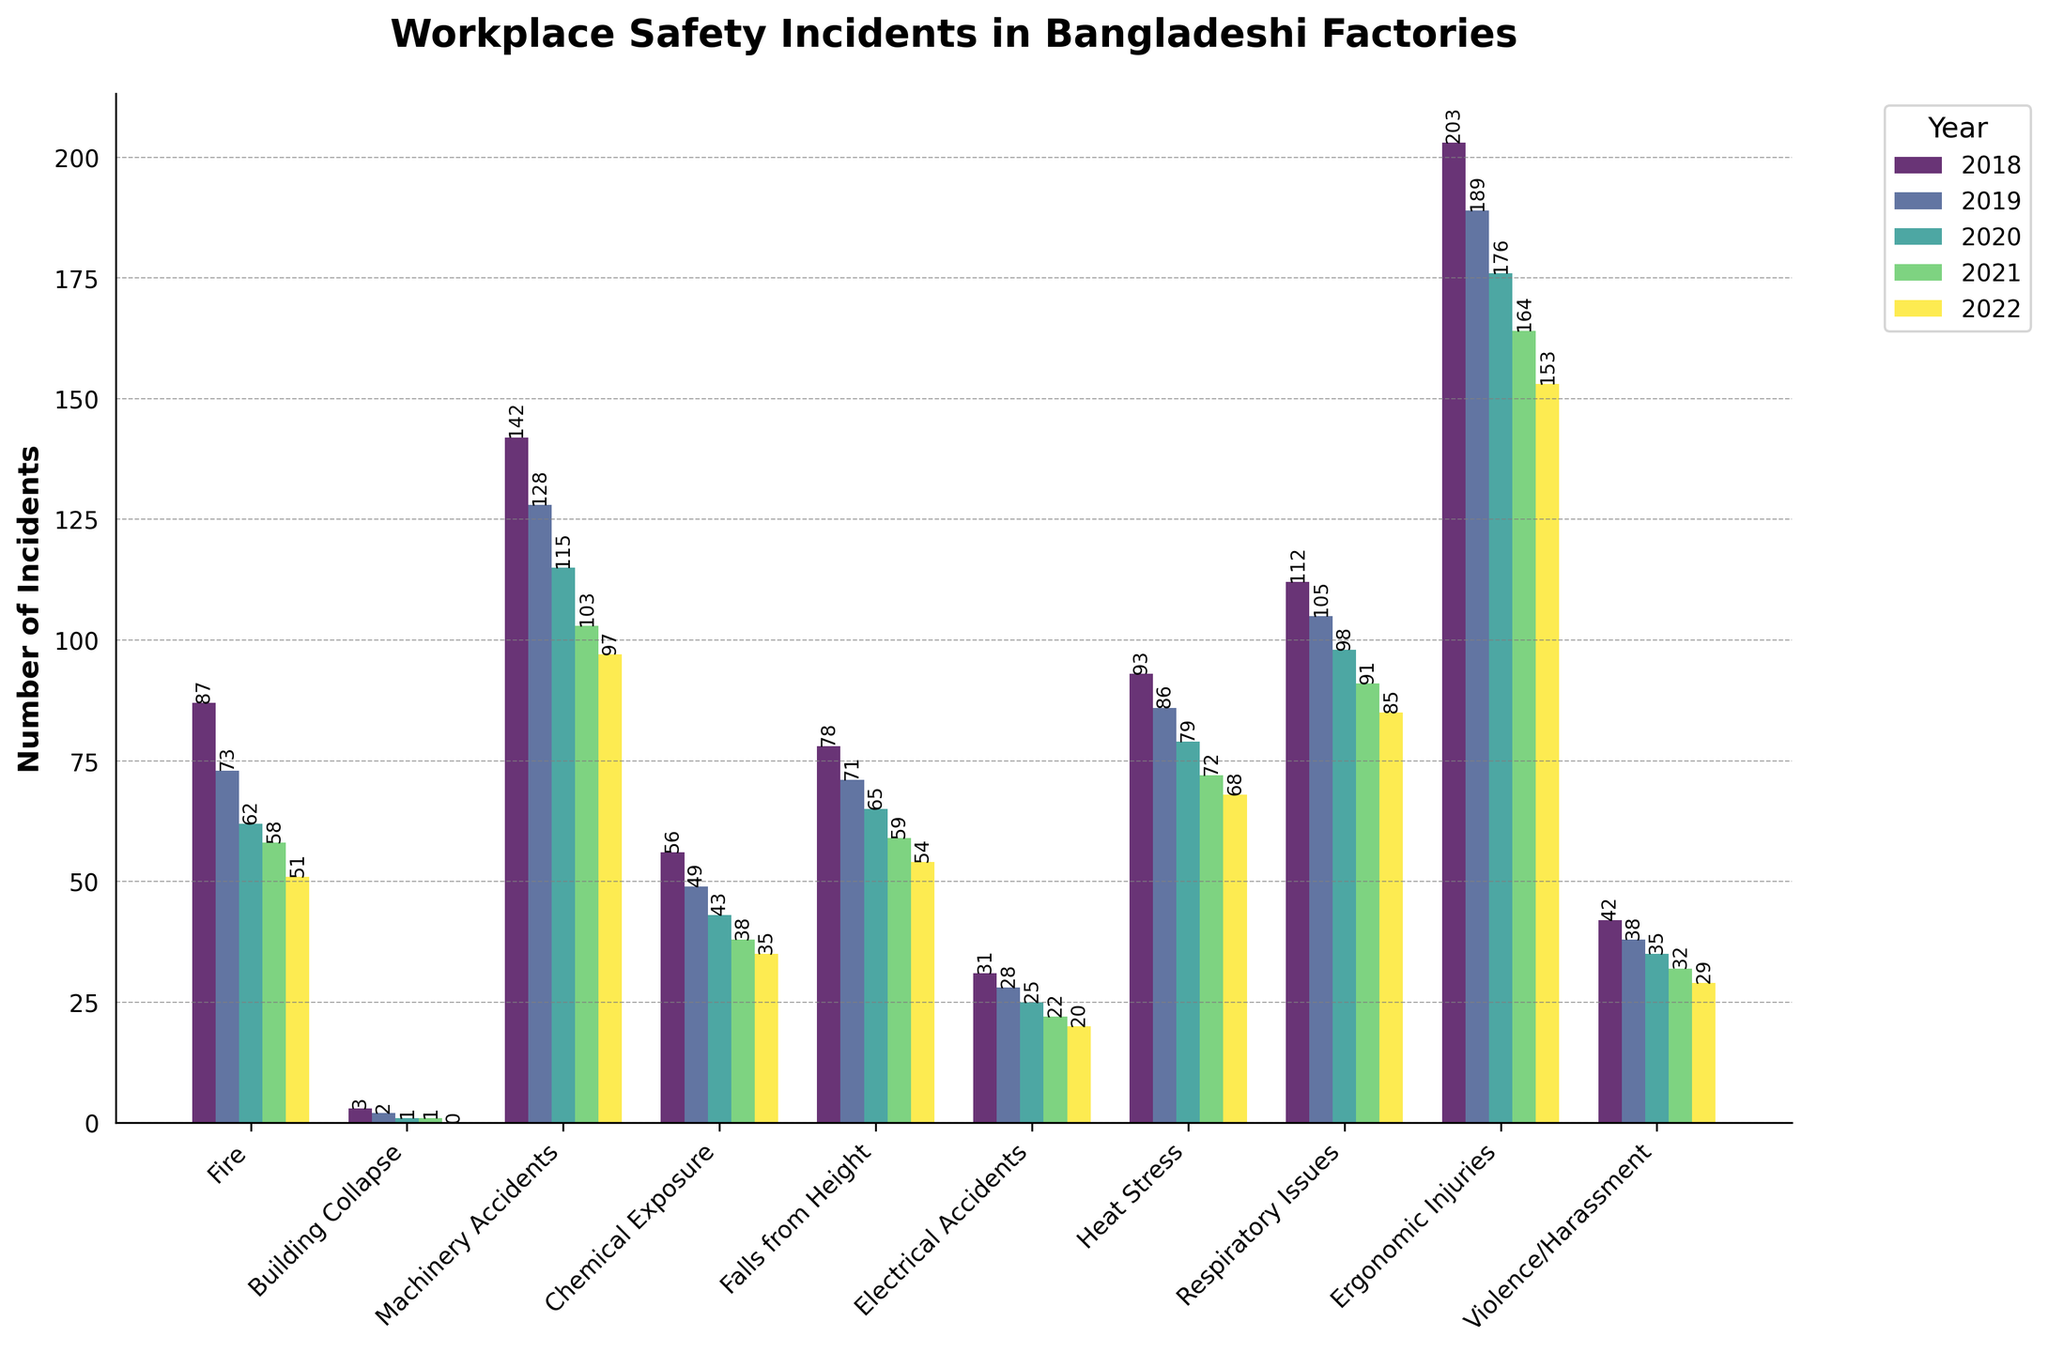What's the most common type of incident in 2022? From the bar chart, find the tallest bar for the year 2022. The tallest bar corresponds to "Ergonomic Injuries"
Answer: Ergonomic Injuries Compare the number of Fire incidents between 2018 and 2022. Which year had more incidents? Locate the bars corresponding to Fire incidents for 2018 and 2022, then compare their heights. 2018 has a taller bar
Answer: 2018 What is the total number of Machinery Accidents over the 5 years? Sum the values of Machinery Accidents for each year: 142 (2018) + 128 (2019) + 115 (2020) + 103 (2021) + 97 (2022) = 585
Answer: 585 Which type of incident decreased the most from 2018 to 2022? For each incident type, subtract the 2022 value from the 2018 value. The incident with the largest difference is "Ergonomic Injuries": 203 - 153 = 50
Answer: Ergonomic Injuries Was there any type of incident that had zero occurrences in 2022? Check each incident type's bar for 2022; "Building Collapse" has a value of 0
Answer: Building Collapse Between Chemical Exposure and Electrical Accidents, which had fewer incidents overall in the 5 years? Sum the incidents for each: Chemical Exposure = 56 + 49 + 43 + 38 + 35 = 221, Electrical Accidents = 31 + 28 + 25 + 22 + 20 = 126. Electrical Accidents has fewer
Answer: Electrical Accidents What's the average number of Heat Stress incidents per year? Sum the Heat Stress incidents over the 5 years and divide by 5: (93 + 86 + 79 + 72 + 68) / 5 = 398 / 5 = 79.6
Answer: 79.6 Which year had the highest number of total incidents across all types? Sum the incidents for each year across all types and compare: 2018 has the largest total (87+3+142+56+78+31+93+112+203+42 = 847)
Answer: 2018 How did Falls from Height incidents trend over the 5 years? Observe the bar heights for Falls from Height; each year shows a decreasing trend: 78 in 2018 to 54 in 2022
Answer: Decreasing Are there any years when Violence/Harassment incidents never increased compared to the previous year? For each year, check if the number of incidents increased from the previous year. Violence/Harassment shows a constant decrease: 42 -> 38 -> 35 -> 32 -> 29
Answer: Yes 